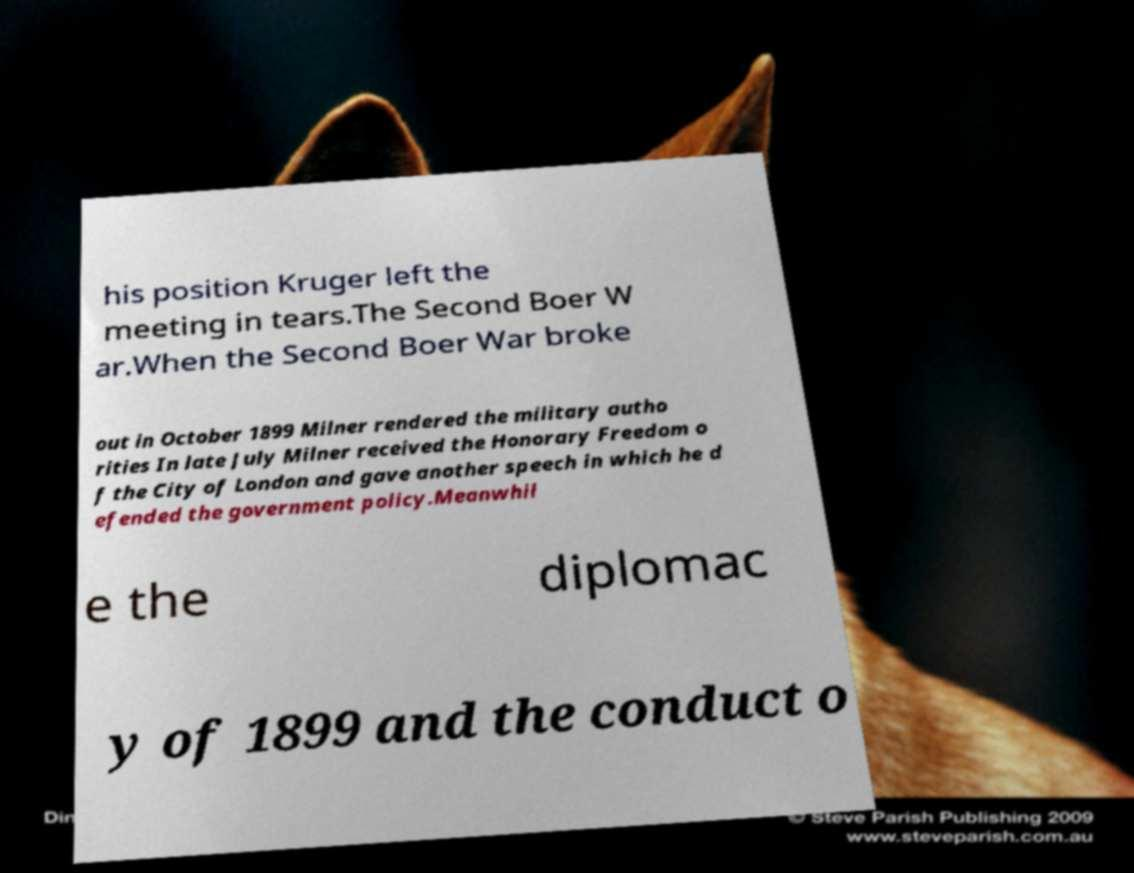Could you assist in decoding the text presented in this image and type it out clearly? his position Kruger left the meeting in tears.The Second Boer W ar.When the Second Boer War broke out in October 1899 Milner rendered the military autho rities In late July Milner received the Honorary Freedom o f the City of London and gave another speech in which he d efended the government policy.Meanwhil e the diplomac y of 1899 and the conduct o 